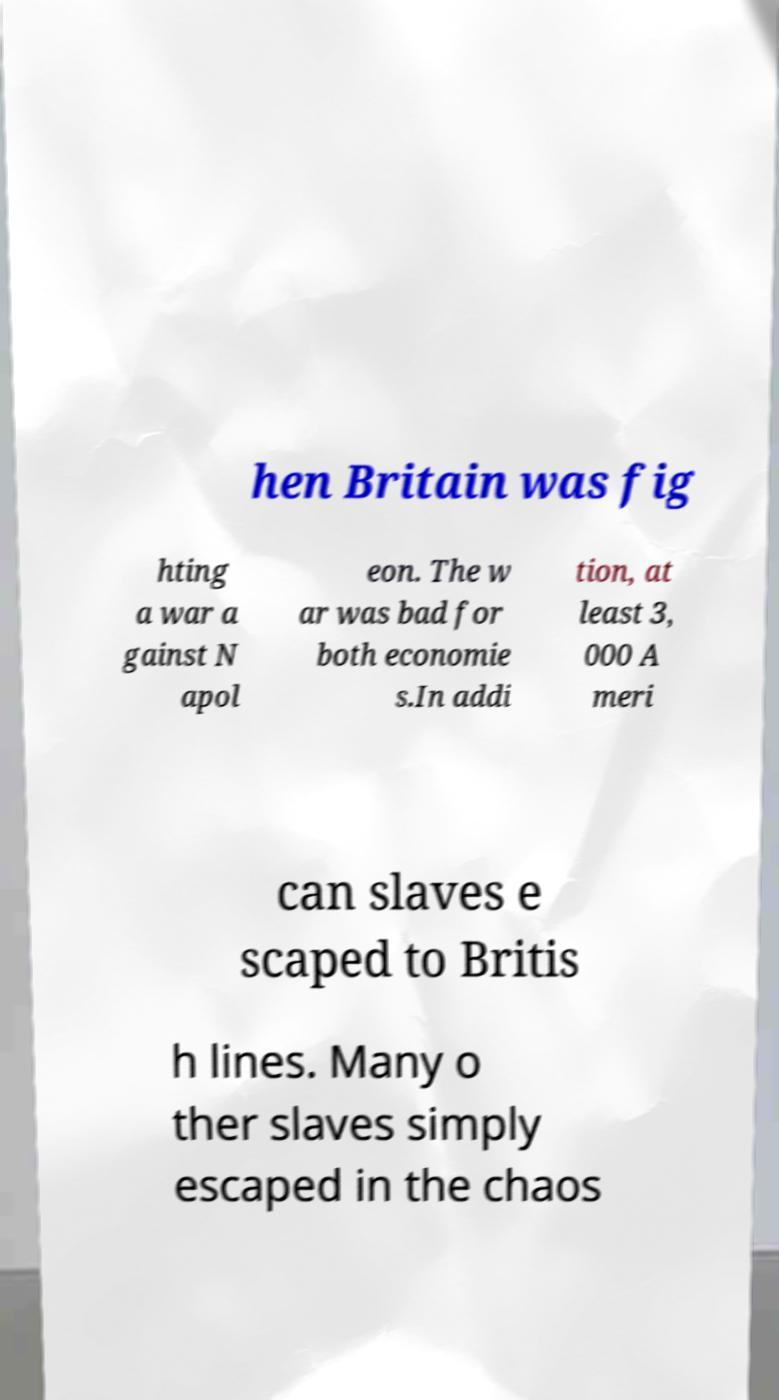Please identify and transcribe the text found in this image. hen Britain was fig hting a war a gainst N apol eon. The w ar was bad for both economie s.In addi tion, at least 3, 000 A meri can slaves e scaped to Britis h lines. Many o ther slaves simply escaped in the chaos 